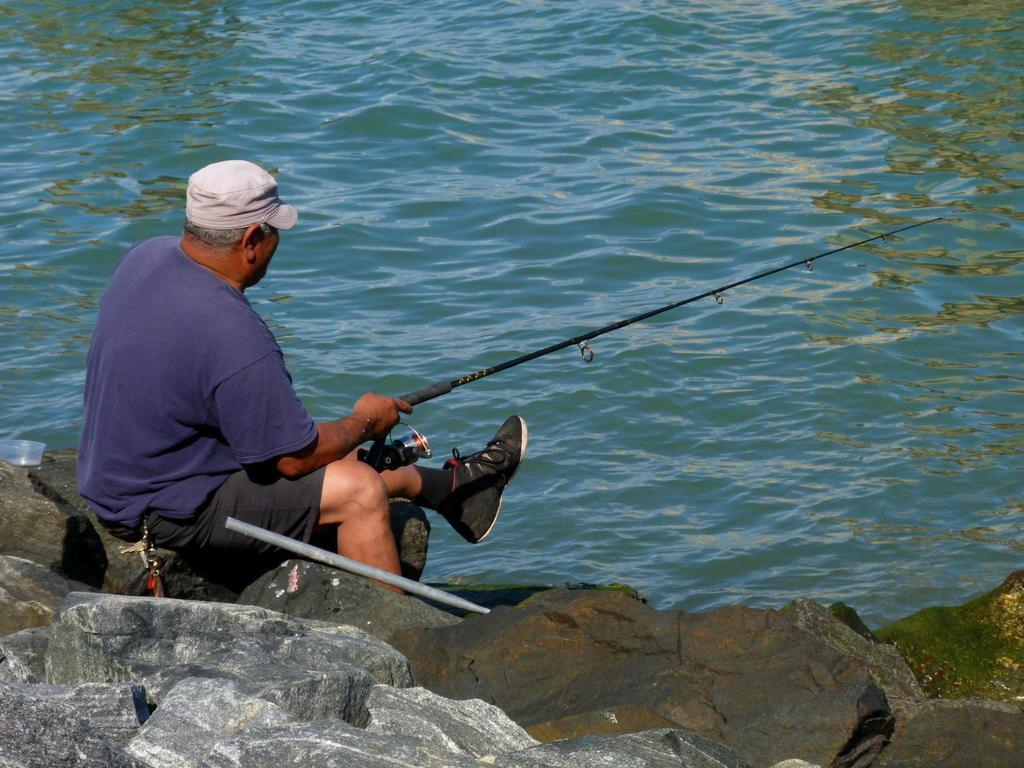What can be seen in the image? There is a person in the image. Can you describe the person's attire? The person is wearing a cap. What is the person holding in the image? The person is holding an object. What type of natural elements are visible in the image? There are stones and water visible in the image. Are there any other objects present in the image besides the person and the object they are holding? Yes, there are other objects in the image. What type of stitch is the person using to repair the kite in the image? There is no kite present in the image, and the person is not engaged in any repair activities. 